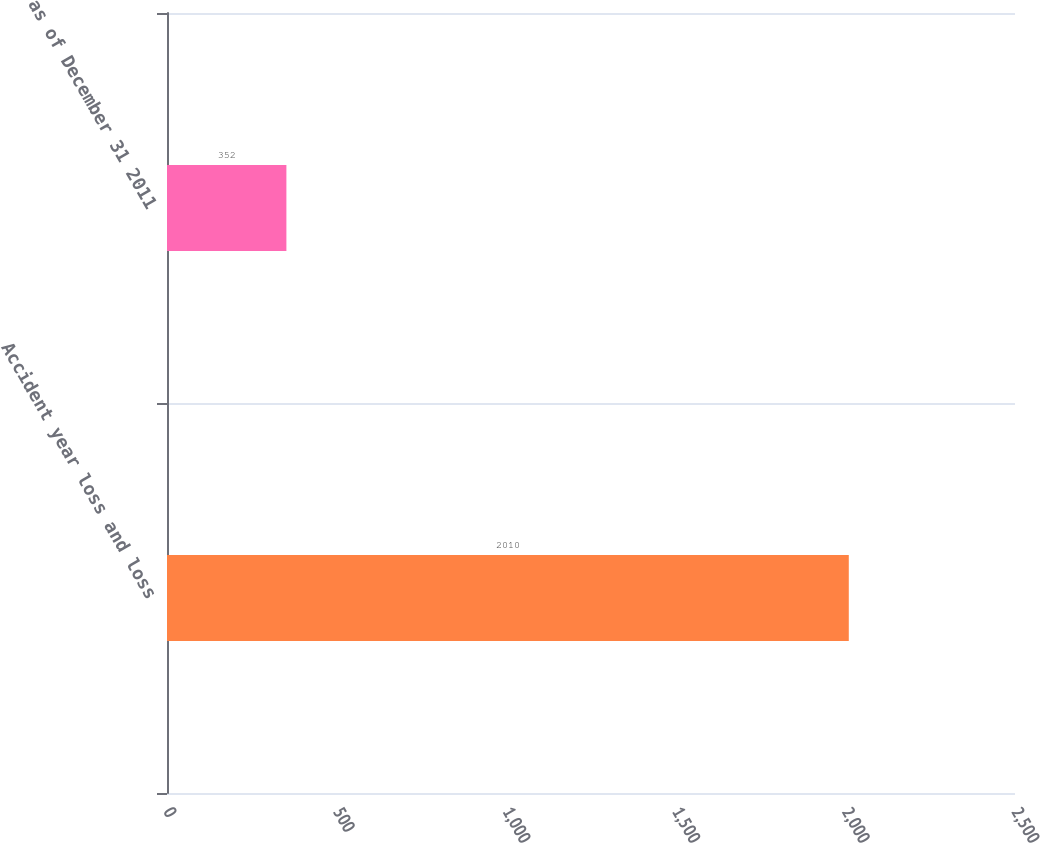Convert chart to OTSL. <chart><loc_0><loc_0><loc_500><loc_500><bar_chart><fcel>Accident year loss and loss<fcel>as of December 31 2011<nl><fcel>2010<fcel>352<nl></chart> 